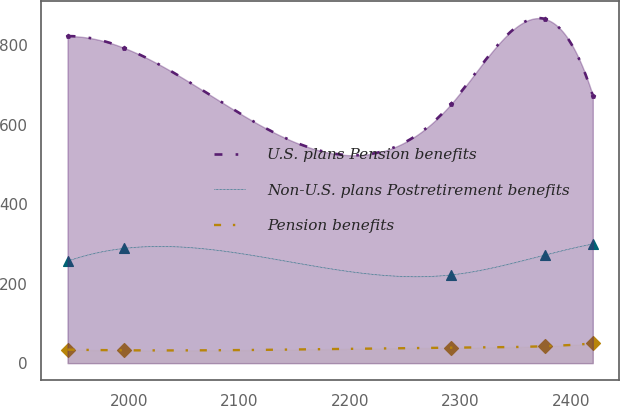Convert chart. <chart><loc_0><loc_0><loc_500><loc_500><line_chart><ecel><fcel>U.S. plans Pension benefits<fcel>Non-U.S. plans Postretirement benefits<fcel>Pension benefits<nl><fcel>1944.29<fcel>823.04<fcel>256.76<fcel>34.08<nl><fcel>1995.65<fcel>793.3<fcel>288.88<fcel>32.36<nl><fcel>2291.33<fcel>651.96<fcel>221.99<fcel>38.88<nl><fcel>2376.2<fcel>866.41<fcel>272<fcel>42.68<nl><fcel>2419.72<fcel>673.4<fcel>299.92<fcel>49.56<nl></chart> 